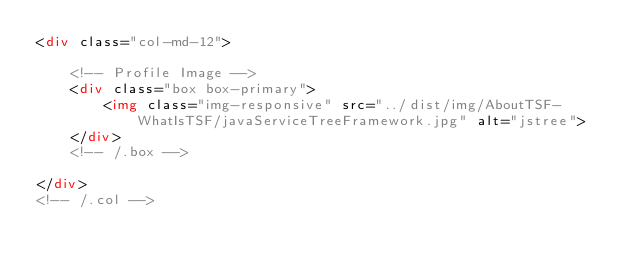Convert code to text. <code><loc_0><loc_0><loc_500><loc_500><_HTML_><div class="col-md-12">

    <!-- Profile Image -->
    <div class="box box-primary">
        <img class="img-responsive" src="../dist/img/AboutTSF-WhatIsTSF/javaServiceTreeFramework.jpg" alt="jstree">
    </div>
    <!-- /.box -->

</div>
<!-- /.col --></code> 